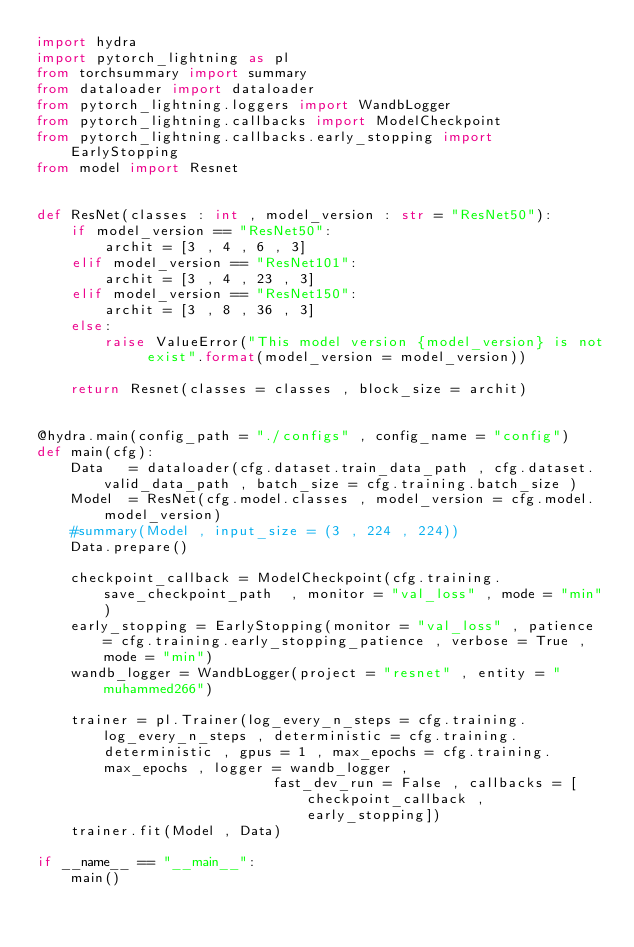Convert code to text. <code><loc_0><loc_0><loc_500><loc_500><_Python_>import hydra
import pytorch_lightning as pl
from torchsummary import summary
from dataloader import dataloader
from pytorch_lightning.loggers import WandbLogger
from pytorch_lightning.callbacks import ModelCheckpoint
from pytorch_lightning.callbacks.early_stopping import EarlyStopping
from model import Resnet


def ResNet(classes : int , model_version : str = "ResNet50"):
    if model_version == "ResNet50":
        archit = [3 , 4 , 6 , 3]
    elif model_version == "ResNet101":
        archit = [3 , 4 , 23 , 3]
    elif model_version == "ResNet150":
        archit = [3 , 8 , 36 , 3]
    else:
        raise ValueError("This model version {model_version} is not exist".format(model_version = model_version))

    return Resnet(classes = classes , block_size = archit)


@hydra.main(config_path = "./configs" , config_name = "config")
def main(cfg):
    Data   = dataloader(cfg.dataset.train_data_path , cfg.dataset.valid_data_path , batch_size = cfg.training.batch_size )
    Model  = ResNet(cfg.model.classes , model_version = cfg.model.model_version)
    #summary(Model , input_size = (3 , 224 , 224))
    Data.prepare()

    checkpoint_callback = ModelCheckpoint(cfg.training.save_checkpoint_path  , monitor = "val_loss" , mode = "min")
    early_stopping = EarlyStopping(monitor = "val_loss" , patience = cfg.training.early_stopping_patience , verbose = True , mode = "min")
    wandb_logger = WandbLogger(project = "resnet" , entity = "muhammed266")

    trainer = pl.Trainer(log_every_n_steps = cfg.training.log_every_n_steps , deterministic = cfg.training.deterministic , gpus = 1 , max_epochs = cfg.training.max_epochs , logger = wandb_logger ,
                            fast_dev_run = False , callbacks = [checkpoint_callback , early_stopping])
    trainer.fit(Model , Data)

if __name__ == "__main__":
    main()
</code> 